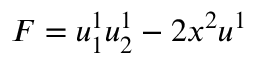Convert formula to latex. <formula><loc_0><loc_0><loc_500><loc_500>F = u _ { 1 } ^ { 1 } u _ { 2 } ^ { 1 } - 2 x ^ { 2 } u ^ { 1 }</formula> 